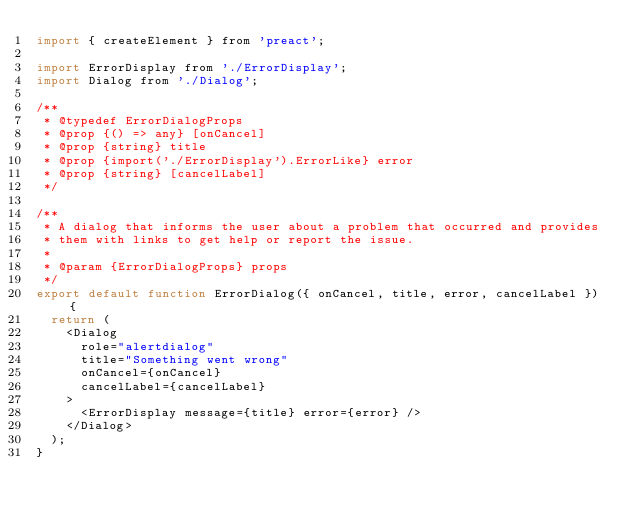Convert code to text. <code><loc_0><loc_0><loc_500><loc_500><_JavaScript_>import { createElement } from 'preact';

import ErrorDisplay from './ErrorDisplay';
import Dialog from './Dialog';

/**
 * @typedef ErrorDialogProps
 * @prop {() => any} [onCancel]
 * @prop {string} title
 * @prop {import('./ErrorDisplay').ErrorLike} error
 * @prop {string} [cancelLabel]
 */

/**
 * A dialog that informs the user about a problem that occurred and provides
 * them with links to get help or report the issue.
 *
 * @param {ErrorDialogProps} props
 */
export default function ErrorDialog({ onCancel, title, error, cancelLabel }) {
  return (
    <Dialog
      role="alertdialog"
      title="Something went wrong"
      onCancel={onCancel}
      cancelLabel={cancelLabel}
    >
      <ErrorDisplay message={title} error={error} />
    </Dialog>
  );
}
</code> 